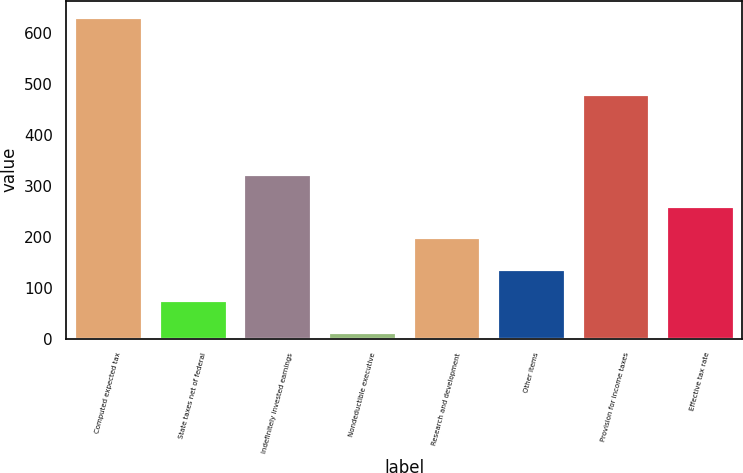Convert chart to OTSL. <chart><loc_0><loc_0><loc_500><loc_500><bar_chart><fcel>Computed expected tax<fcel>State taxes net of federal<fcel>Indefinitely invested earnings<fcel>Nondeductible executive<fcel>Research and development<fcel>Other items<fcel>Provision for income taxes<fcel>Effective tax rate<nl><fcel>633<fcel>75.9<fcel>323.5<fcel>14<fcel>199.7<fcel>137.8<fcel>480<fcel>261.6<nl></chart> 